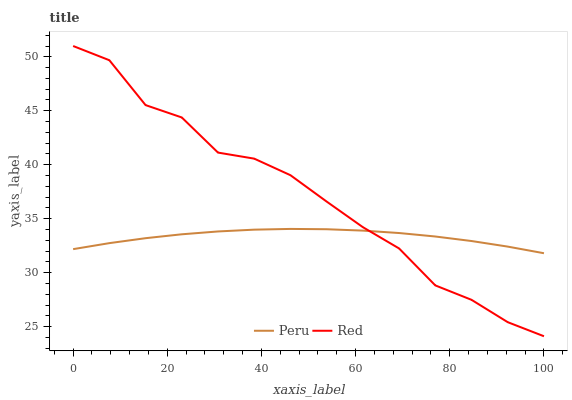Does Peru have the minimum area under the curve?
Answer yes or no. Yes. Does Red have the maximum area under the curve?
Answer yes or no. Yes. Does Peru have the maximum area under the curve?
Answer yes or no. No. Is Peru the smoothest?
Answer yes or no. Yes. Is Red the roughest?
Answer yes or no. Yes. Is Peru the roughest?
Answer yes or no. No. Does Red have the lowest value?
Answer yes or no. Yes. Does Peru have the lowest value?
Answer yes or no. No. Does Red have the highest value?
Answer yes or no. Yes. Does Peru have the highest value?
Answer yes or no. No. Does Peru intersect Red?
Answer yes or no. Yes. Is Peru less than Red?
Answer yes or no. No. Is Peru greater than Red?
Answer yes or no. No. 